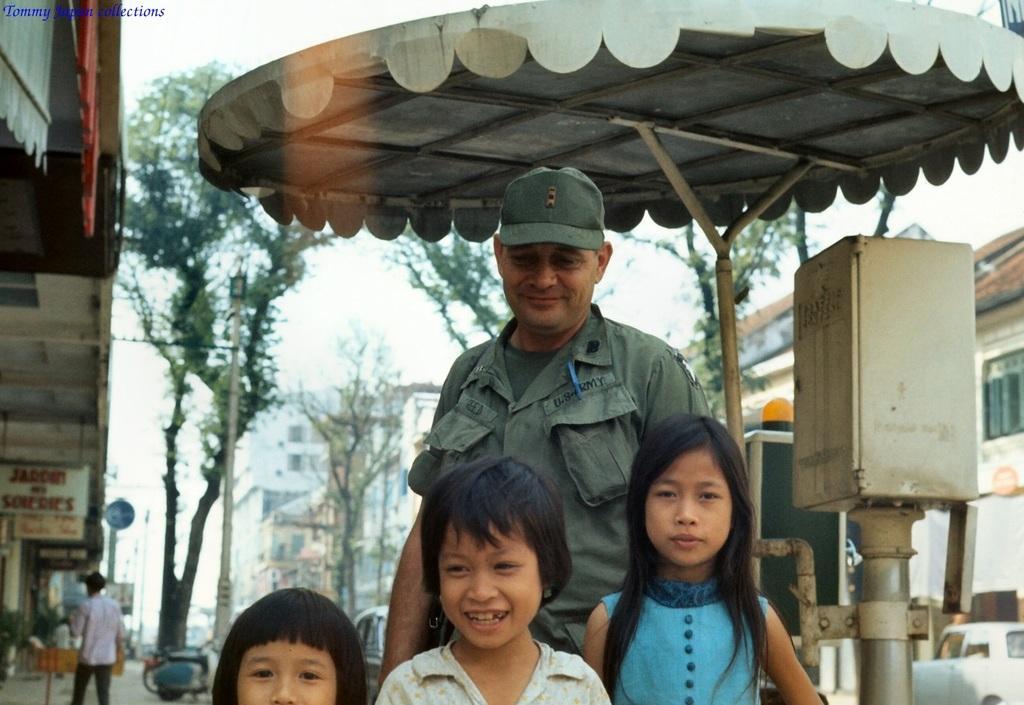Describe this image in one or two sentences. In this image I can see few children and few people are standing. I can also see smile on few faces. In the background I can see few trees, number of buildings, few poles and I can see this image is little bit blurry from background. I can also see something is written over there. 